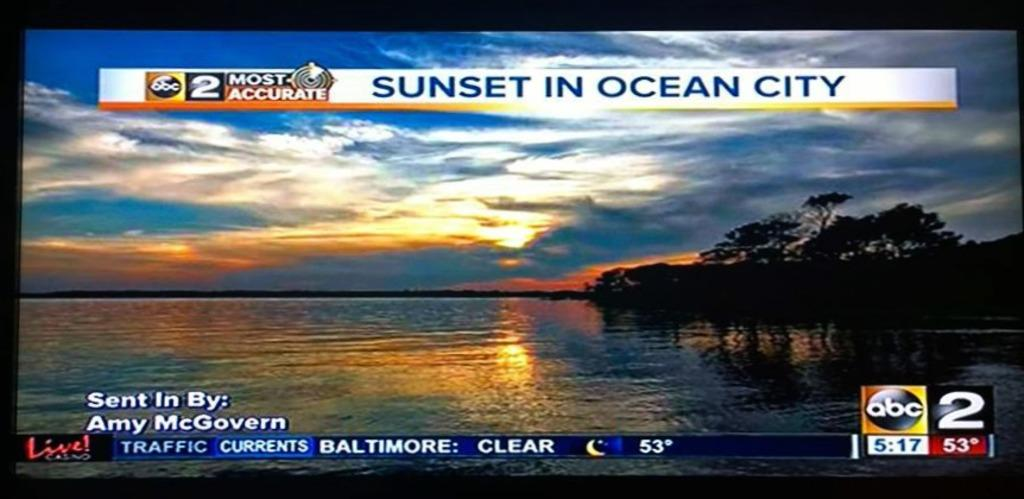<image>
Share a concise interpretation of the image provided. The TV is showing a news story from ABC 2 called Sunset in Ocean City. 